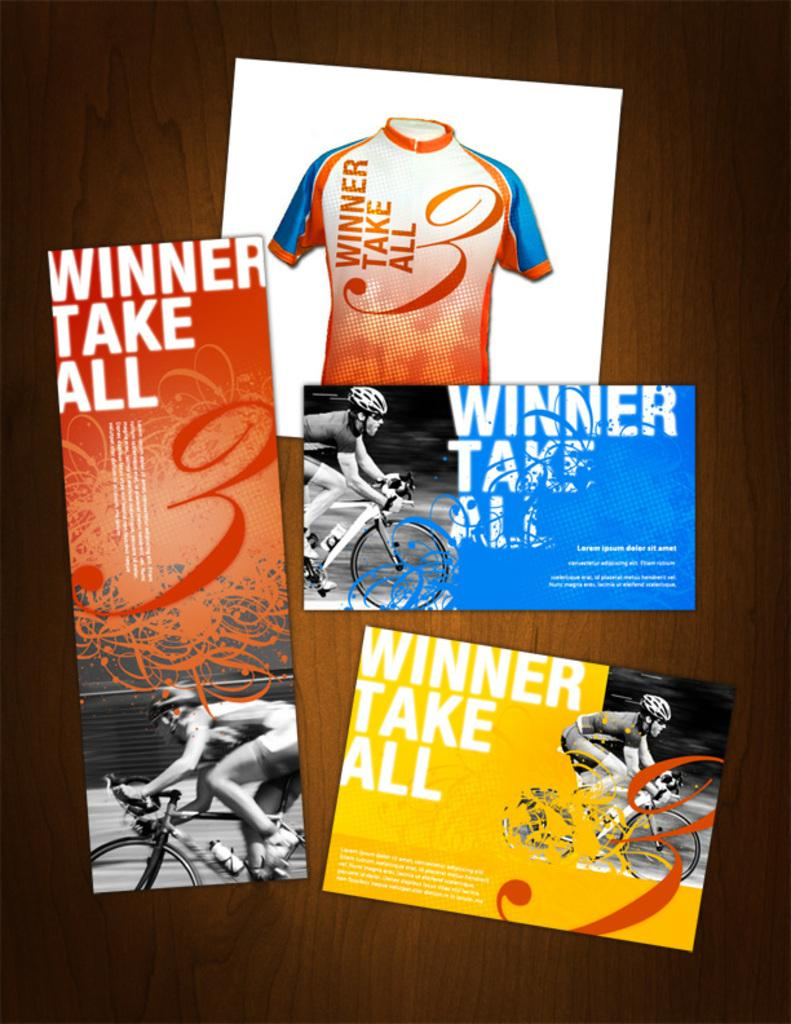Provide a one-sentence caption for the provided image. Marketing materials for cyclists that feature the winner take all motto. 